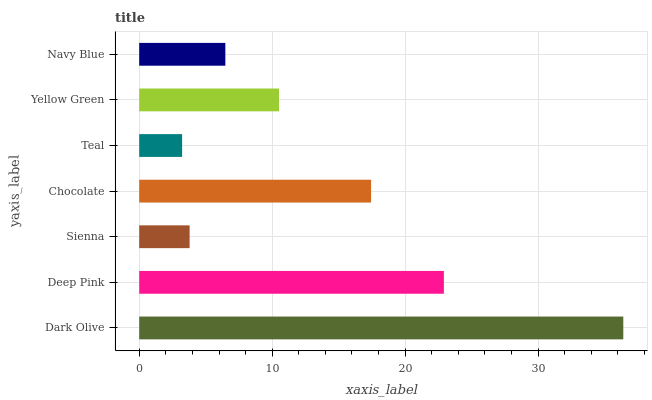Is Teal the minimum?
Answer yes or no. Yes. Is Dark Olive the maximum?
Answer yes or no. Yes. Is Deep Pink the minimum?
Answer yes or no. No. Is Deep Pink the maximum?
Answer yes or no. No. Is Dark Olive greater than Deep Pink?
Answer yes or no. Yes. Is Deep Pink less than Dark Olive?
Answer yes or no. Yes. Is Deep Pink greater than Dark Olive?
Answer yes or no. No. Is Dark Olive less than Deep Pink?
Answer yes or no. No. Is Yellow Green the high median?
Answer yes or no. Yes. Is Yellow Green the low median?
Answer yes or no. Yes. Is Dark Olive the high median?
Answer yes or no. No. Is Teal the low median?
Answer yes or no. No. 